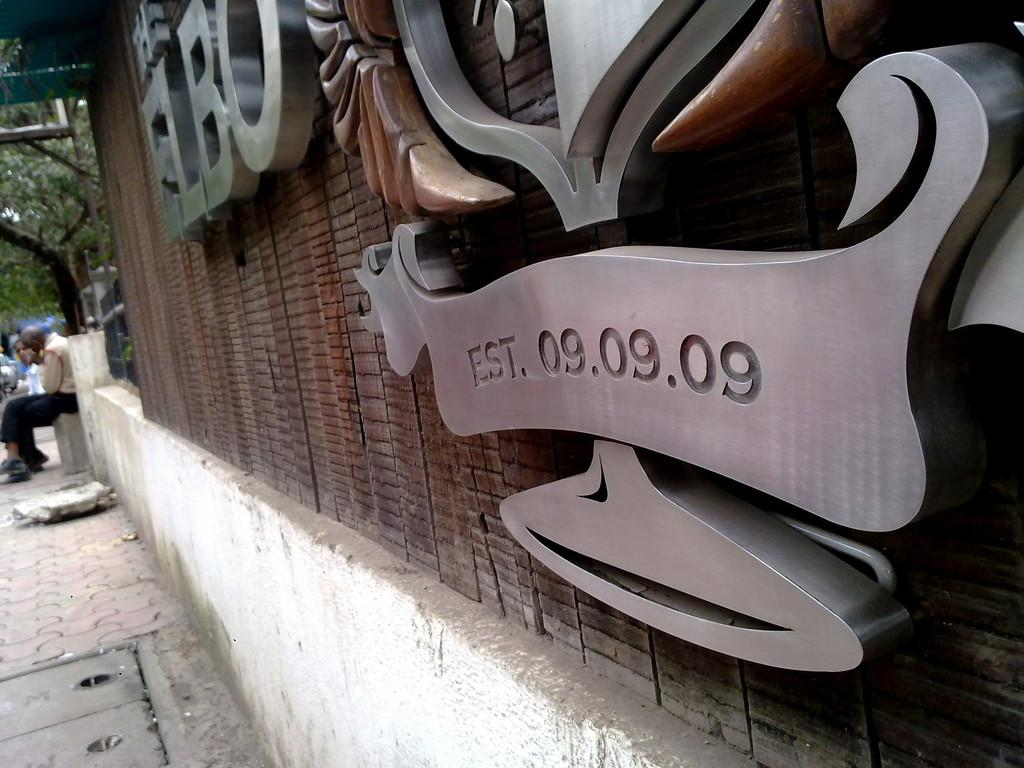What is attached to the wall in the image? There are boards on the wall in the image. What can be seen on the ground in the image? There is a path in the image. Can you describe the people in the background of the image? There are two people in the background of the image. What type of vegetation is visible in the background of the image? There is a tree visible in the background of the image. What type of drink is being served by the laborer in the image? There is no laborer or drink present in the image. How many horses can be seen in the image? There are no horses present in the image. 